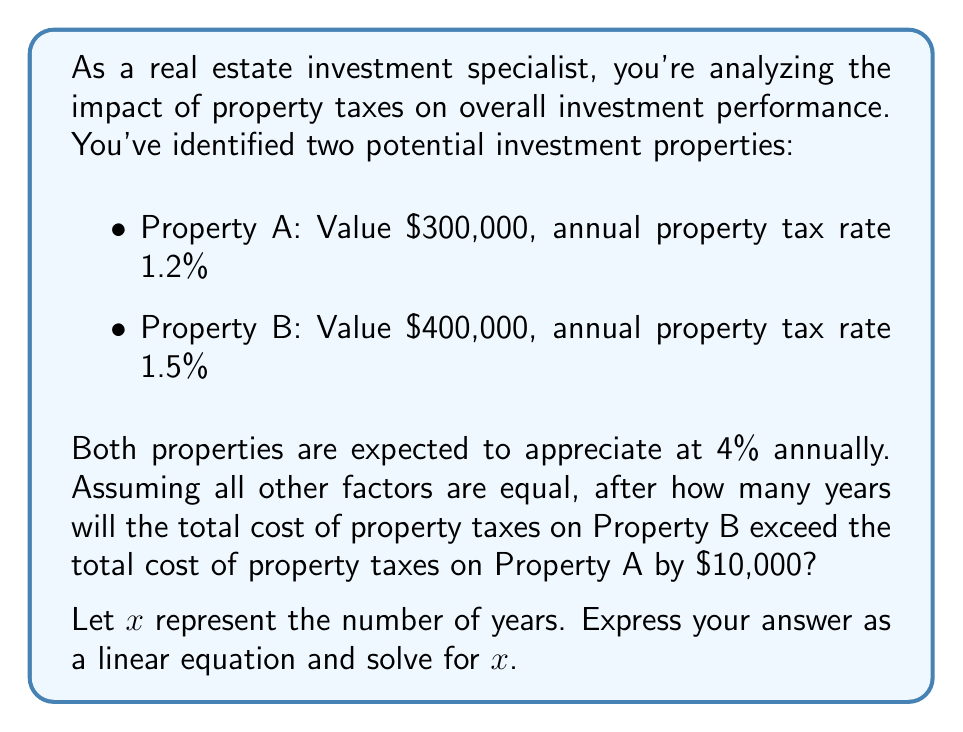Provide a solution to this math problem. To solve this problem, we need to:
1. Calculate the annual property tax for each property
2. Express the total property tax paid over $x$ years for each property
3. Set up an equation where the difference between these totals equals $10,000
4. Solve the resulting linear equation for $x$

Step 1: Calculate annual property tax
Property A: $300,000 * 0.012 = $3,600
Property B: $400,000 * 0.015 = $6,000

Step 2: Express total property tax over $x$ years
We need to account for the 4% annual appreciation. The sum of a geometric series formula will be useful here:

$S_n = a\frac{1-r^n}{1-r}$, where $a$ is the first term, $r$ is the common ratio, and $n$ is the number of terms.

Property A: $3,600 \frac{1-(1.04)^x}{1-1.04} = 3,600 \frac{1-(1.04)^x}{-0.04}$
Property B: $6,000 \frac{1-(1.04)^x}{1-1.04} = 6,000 \frac{1-(1.04)^x}{-0.04}$

Step 3: Set up the equation
$$6,000 \frac{1-(1.04)^x}{-0.04} - 3,600 \frac{1-(1.04)^x}{-0.04} = 10,000$$

Step 4: Solve for $x$
Simplify the left side of the equation:
$$(6,000 - 3,600) \frac{1-(1.04)^x}{-0.04} = 10,000$$
$$2,400 \frac{1-(1.04)^x}{-0.04} = 10,000$$
$$2,400 (1-(1.04)^x) = -400$$
$$1-(1.04)^x = -\frac{1}{6}$$
$$(1.04)^x = \frac{7}{6}$$

Taking the natural log of both sides:
$$x \ln(1.04) = \ln(\frac{7}{6})$$
$$x = \frac{\ln(\frac{7}{6})}{\ln(1.04)} \approx 4.37$$

Since we're dealing with whole years, we round up to 5 years.
Answer: The linear equation is:
$$2,400 \frac{1-(1.04)^x}{-0.04} = 10,000$$

Solving for $x$ gives approximately 4.37 years. Rounding up to the nearest whole year, the answer is 5 years. 